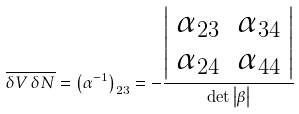<formula> <loc_0><loc_0><loc_500><loc_500>\overline { \delta V \, \delta N } = \left ( \alpha ^ { - 1 } \right ) _ { 2 3 } = - \frac { \left | \begin{array} { l l } \alpha _ { 2 3 } & \alpha _ { 3 4 } \\ \alpha _ { 2 4 } & \alpha _ { 4 4 } \end{array} \right | } { \det \left | \beta \right | }</formula> 